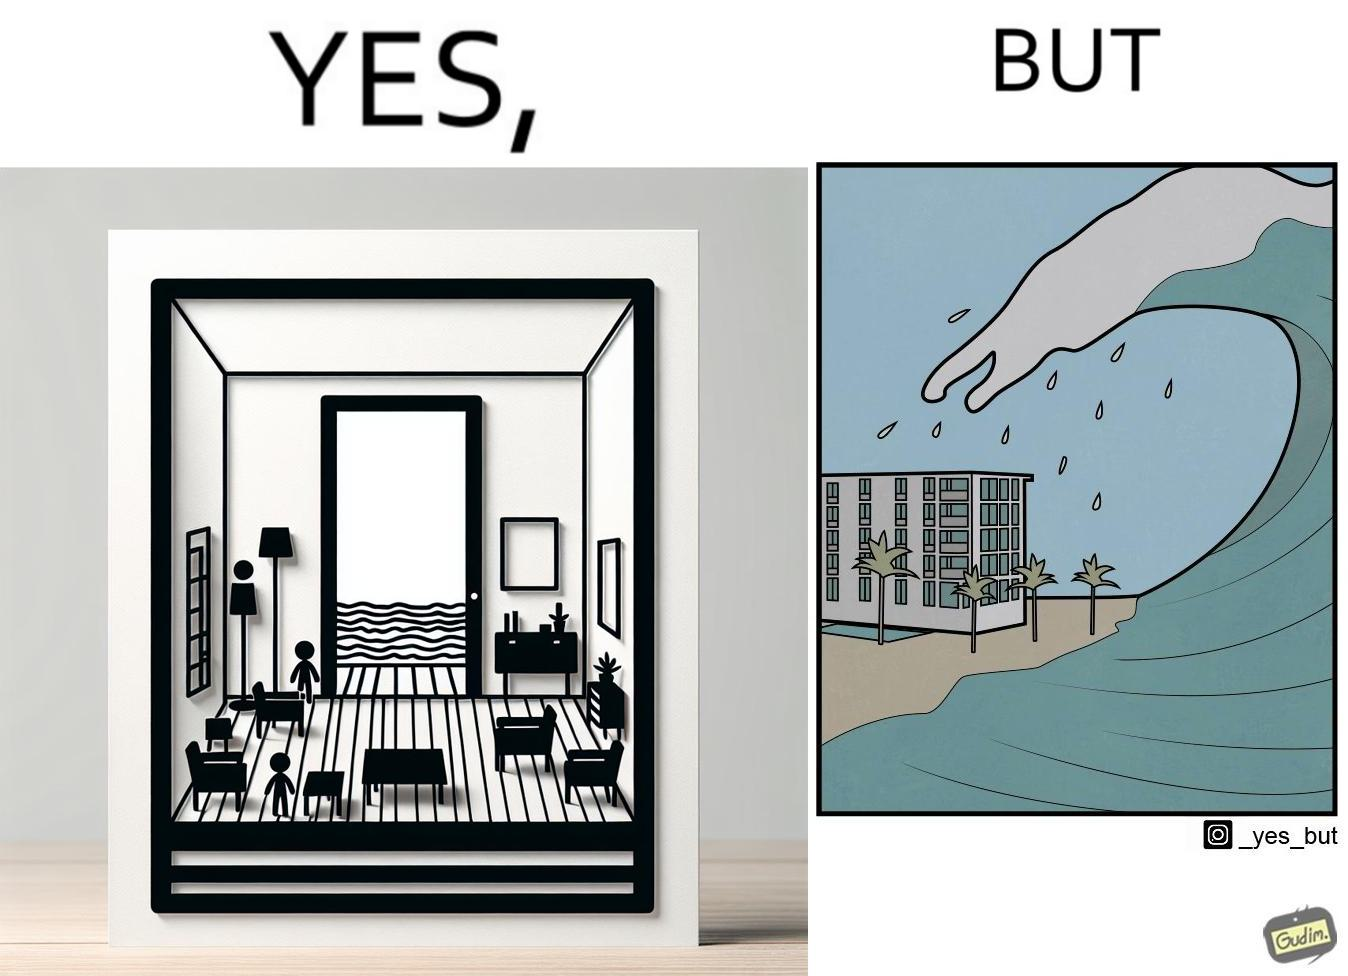What do you see in each half of this image? In the left part of the image: a room with a sea-facing door In the right part of the image: high waves in the sea twice of the height of the building near the sea 